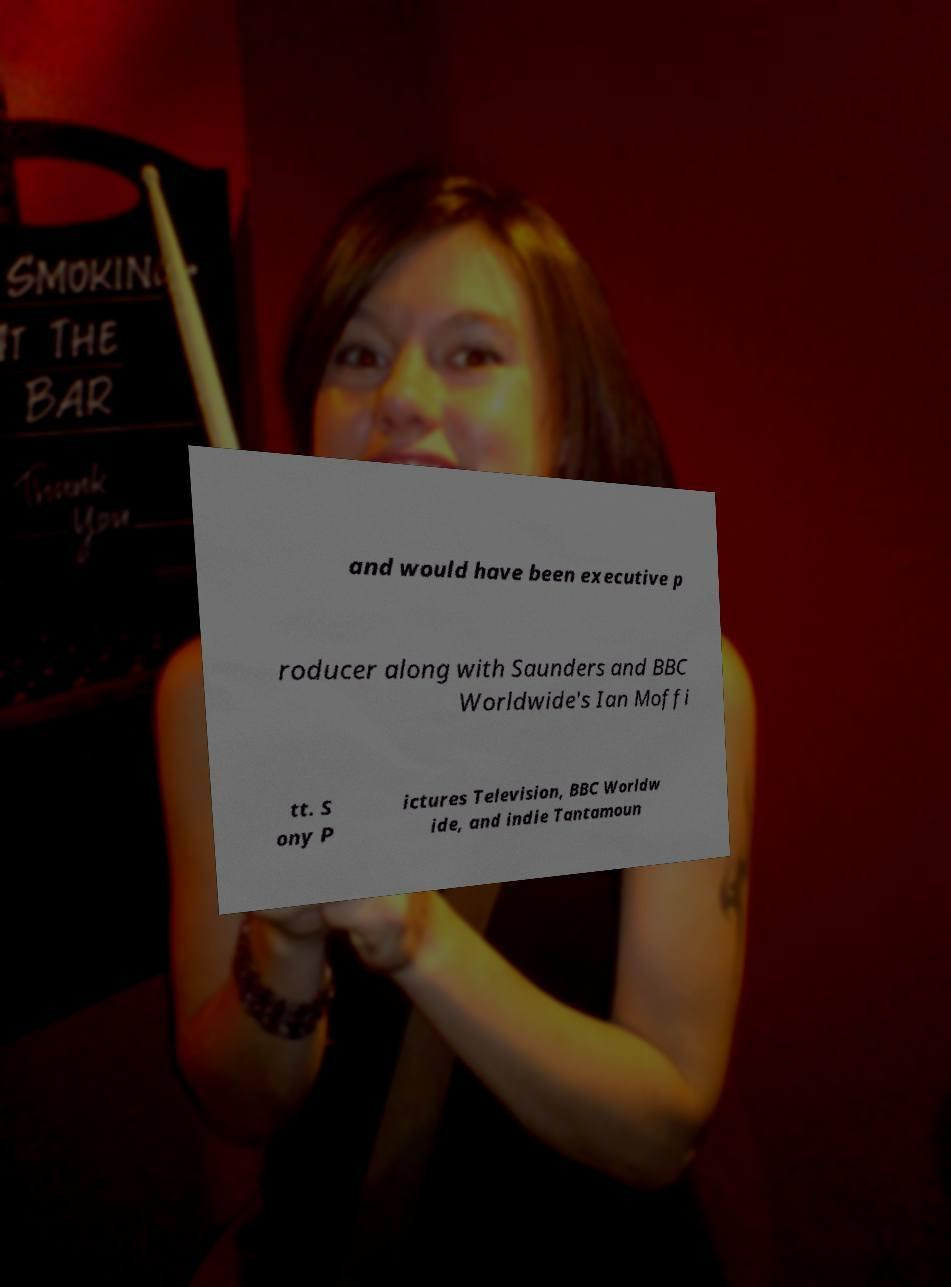Can you accurately transcribe the text from the provided image for me? and would have been executive p roducer along with Saunders and BBC Worldwide's Ian Moffi tt. S ony P ictures Television, BBC Worldw ide, and indie Tantamoun 